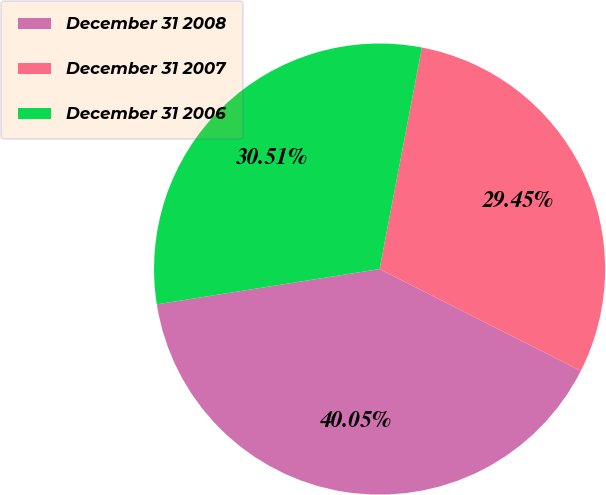Convert chart to OTSL. <chart><loc_0><loc_0><loc_500><loc_500><pie_chart><fcel>December 31 2008<fcel>December 31 2007<fcel>December 31 2006<nl><fcel>40.05%<fcel>29.45%<fcel>30.51%<nl></chart> 